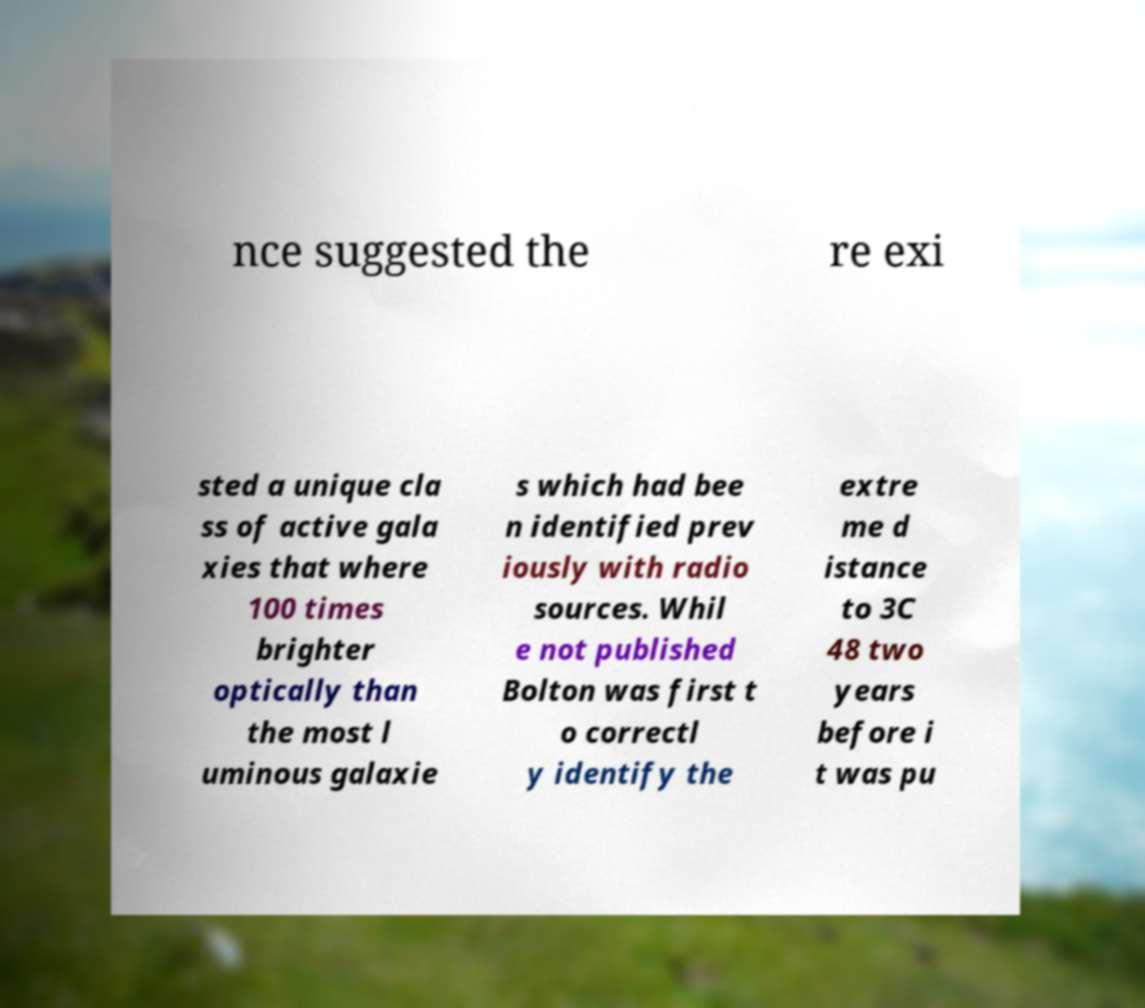Could you extract and type out the text from this image? nce suggested the re exi sted a unique cla ss of active gala xies that where 100 times brighter optically than the most l uminous galaxie s which had bee n identified prev iously with radio sources. Whil e not published Bolton was first t o correctl y identify the extre me d istance to 3C 48 two years before i t was pu 